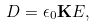Convert formula to latex. <formula><loc_0><loc_0><loc_500><loc_500>D = \epsilon _ { 0 } \mathbf { K } E ,</formula> 